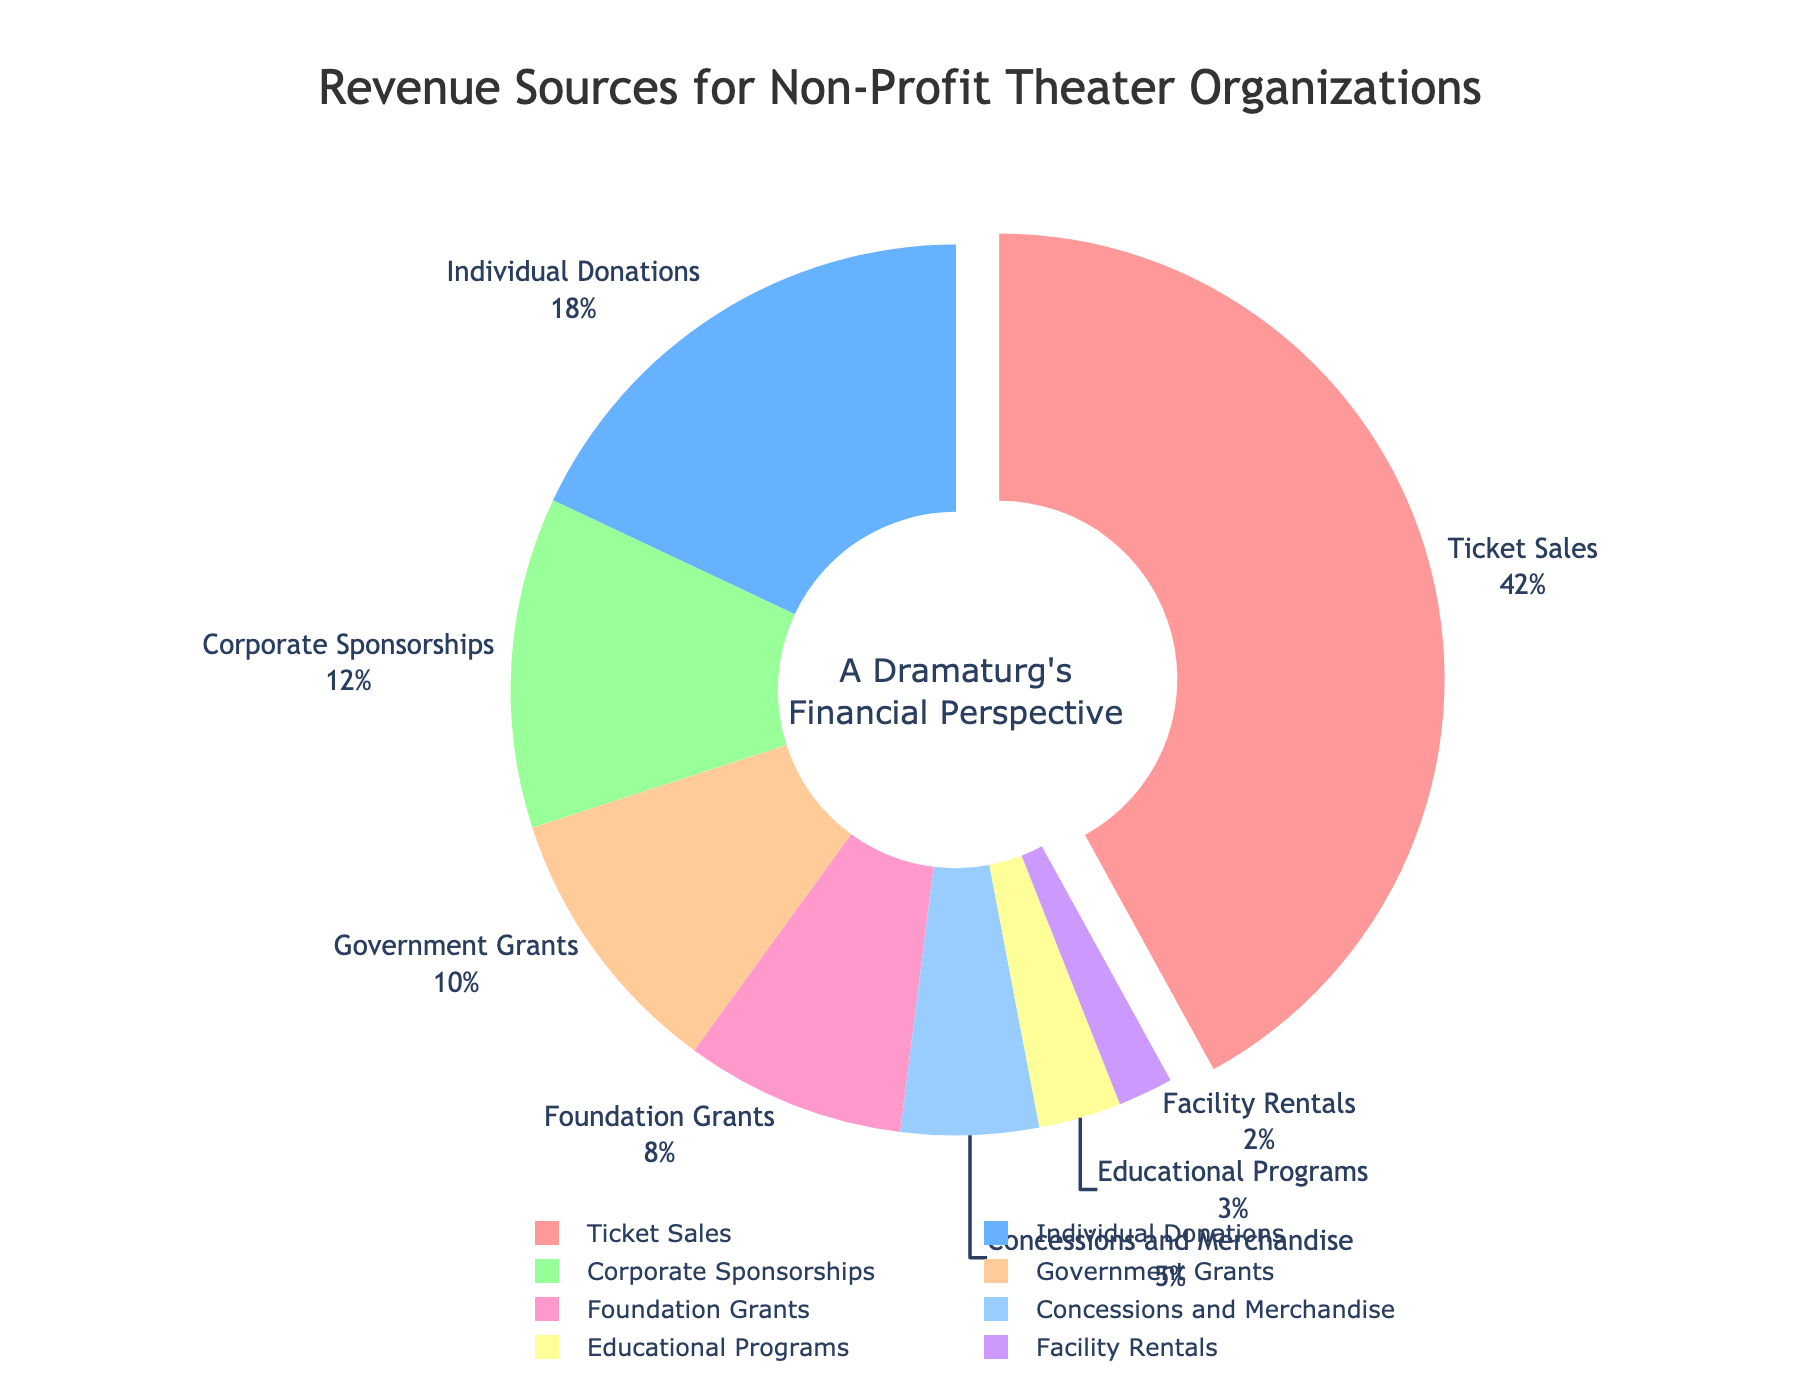Which revenue source contributes the most to the total revenue? The slice of the pie chart with the largest percentage represents the highest contributor. Here, "Ticket Sales" is the largest slice.
Answer: Ticket Sales What is the percentage difference between individual donations and corporate sponsorships? Individual Donations account for 18% and Corporate Sponsorships account for 12%. The difference is calculated as 18% - 12% = 6%.
Answer: 6% How do the combined contributions of Foundation Grants and Government Grants compare to Ticket Sales? Foundation Grants and Government Grants together make 8% + 10% = 18%. Ticket Sales alone contribute 42%. Therefore, their combined contribution is less.
Answer: Less If you combine the revenue from Educational Programs and Facility Rentals, do they exceed the revenue from Concessions and Merchandise? Educational Programs contribute 3% and Facility Rentals contribute 2%. Combined, they make 3% + 2% = 5%, which is equal to the revenue from Concessions and Merchandise.
Answer: Equal Which section has the smallest contribution, and what is its percentage? The smallest segment of the pie chart represents the lowest contribution. "Facility Rentals" is the smallest part and contributes 2%.
Answer: Facility Rentals at 2% What percentage of total revenue comes from non-government sources? Add up all contributions from non-governmental sources: Ticket Sales (42%), Individual Donations (18%), Corporate Sponsorships (12%), Foundation Grants (8%), Concessions and Merchandise (5%), Educational Programs (3%), Facility Rentals (2%). The total is 42% + 18% + 12% + 8% + 5% + 3% + 2% = 90%.
Answer: 90% What proportion of total revenue is contributed by Ticket Sales and Individual Donations together? Ticket Sales account for 42% and Individual Donations account for 18%. Summing these gives 42% + 18% = 60%.
Answer: 60% Is the revenue from Foundation Grants larger than the revenue from Educational Programs and Facility Rentals combined? Foundation Grants contribute 8%. Educational Programs contribute 3% and Facility Rentals contribute 2%, summing to 3% + 2% = 5%. Thus, Foundation Grants contribute more.
Answer: Yes Which two revenue sources together provide a similar contribution as Individual Donations? Individual Donations contribute 18%. Combining Corporate Sponsorships (12%) and Educational Programs (3%) gives 12% + 3% = 15%, which is close but not exactly the same. Another similar combination is not available in the data.
Answer: Corporate Sponsorships and Educational Programs How much more does Ticket Sales contribute compared to the combined revenue from Government and Foundation Grants? Ticket Sales contribute 42%. Government Grants and Foundation Grants together contribute 10% + 8% = 18%. The difference is 42% - 18% = 24%.
Answer: 24% 